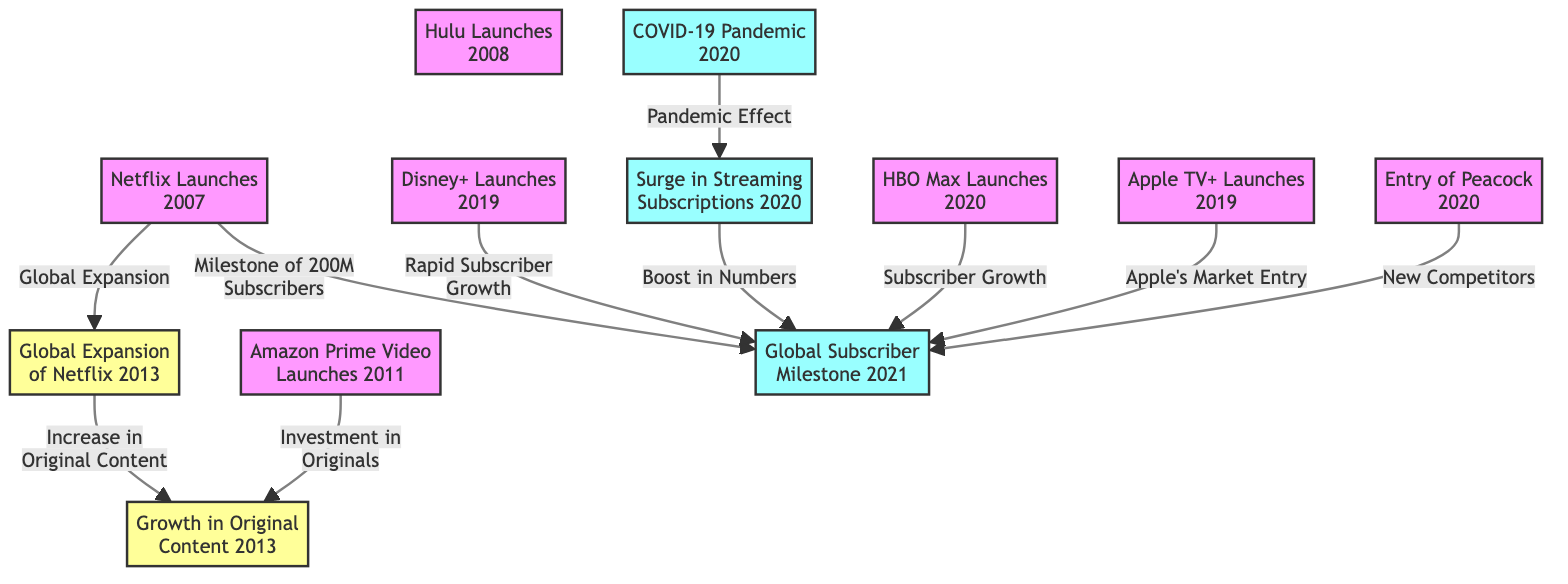What year did Netflix launch? According to the diagram, Netflix launched in 2007. This is indicated by the node labeled "Netflix Launches" which shows the year 2007.
Answer: 2007 What is the relationship between Hulu Launches and Global Subscriber Milestone Reached? In the diagram, there is no direct relationship or edge connecting "Hulu Launches" to "Global Subscriber Milestone Reached." Therefore, they are independent events in this context.
Answer: None How many global streaming services are launched before 2020? The nodes for streaming services launched before 2020 are Netflix (2007), Hulu (2008), and Amazon Prime Video (2011), which totals three services.
Answer: 3 What major global event in 2020 led to a surge in streaming subscriptions? The COVID-19 Pandemic, which is indicated in the diagram and is seen as a key factor influencing increased subscriptions during that time.
Answer: COVID-19 Pandemic Which streaming service launched in 2019 has a connection to the global subscriber milestone reached in 2021? Disney+ launched in 2019, and it has a direct edge to "Global Subscriber Milestone Reached" indicating "Rapid Subscriber Growth."
Answer: Disney+ What is the impact of the COVID-19 Pandemic on streaming services according to the diagram? The diagram shows that the COVID-19 Pandemic directly leads to a "Surge in Streaming Subscriptions," marking it as a significant effect in the timeline.
Answer: Surge in Streaming Subscriptions Which two services launched in 2020 have a direct link to the Global Subscriber Milestone? HBO Max and Peacock both launched in 2020 and are connected to "Global Subscriber Milestone Reached" through edges labeled "Subscriber Growth" and "New Competitors," respectively.
Answer: HBO Max, Peacock How does the global expansion of Netflix relate to the growth in original content? The edge from "Global Expansion of Netflix" to "Growth in Original Content Production" shows that the expansion led to an increase in producing original content for the streaming service.
Answer: Increase in Original Content What event occurred immediately after the launch of Disney+ in 2019? The immediate event after Disney+ Launches is the connection to "Global Subscriber Milestone Reached" indicating that its launch contributed to this milestone.
Answer: Global Subscriber Milestone Reached 